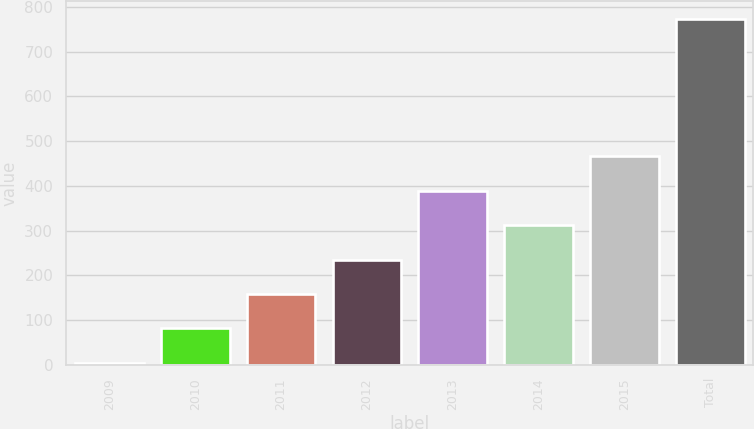<chart> <loc_0><loc_0><loc_500><loc_500><bar_chart><fcel>2009<fcel>2010<fcel>2011<fcel>2012<fcel>2013<fcel>2014<fcel>2015<fcel>Total<nl><fcel>4<fcel>81<fcel>158<fcel>235<fcel>389<fcel>312<fcel>466<fcel>774<nl></chart> 